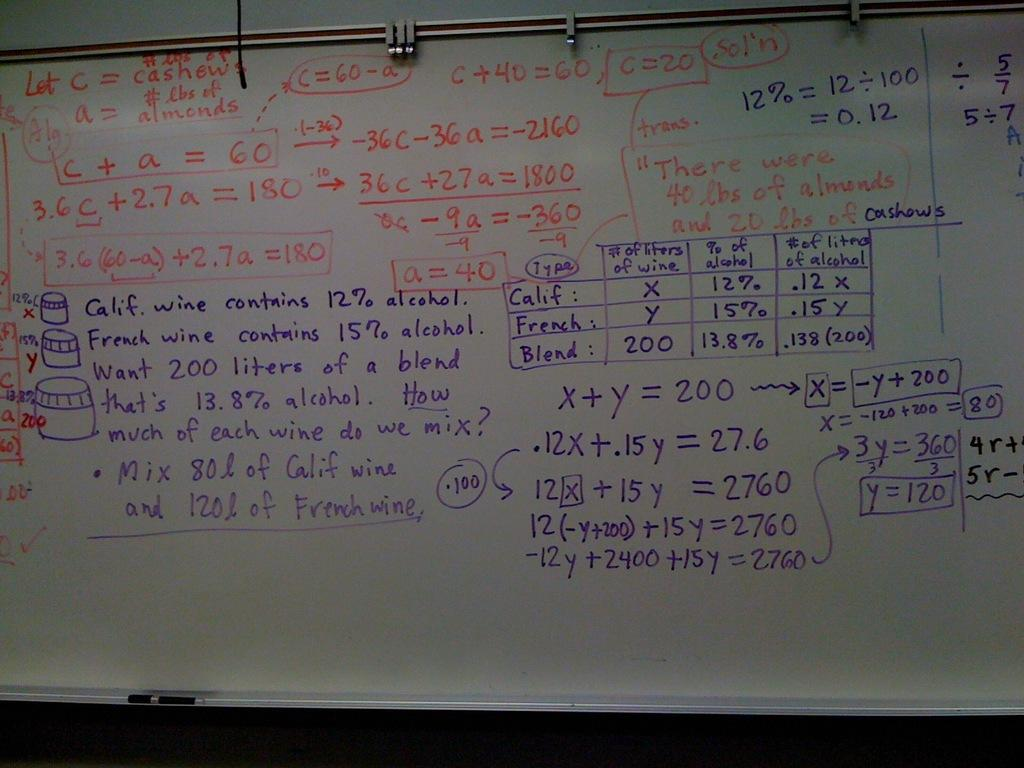<image>
Share a concise interpretation of the image provided. A white board that has math formulas on it, beginning with "Let C = cashew". 